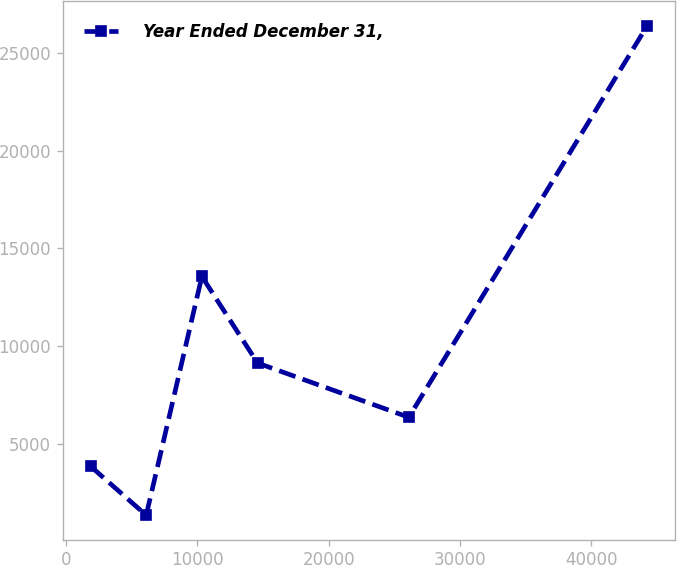Convert chart to OTSL. <chart><loc_0><loc_0><loc_500><loc_500><line_chart><ecel><fcel>Year Ended December 31,<nl><fcel>1866.4<fcel>3853.29<nl><fcel>6106<fcel>1348.03<nl><fcel>10345.6<fcel>13563.9<nl><fcel>14585.2<fcel>9135.2<nl><fcel>26100.9<fcel>6358.55<nl><fcel>44262.4<fcel>26400.6<nl></chart> 